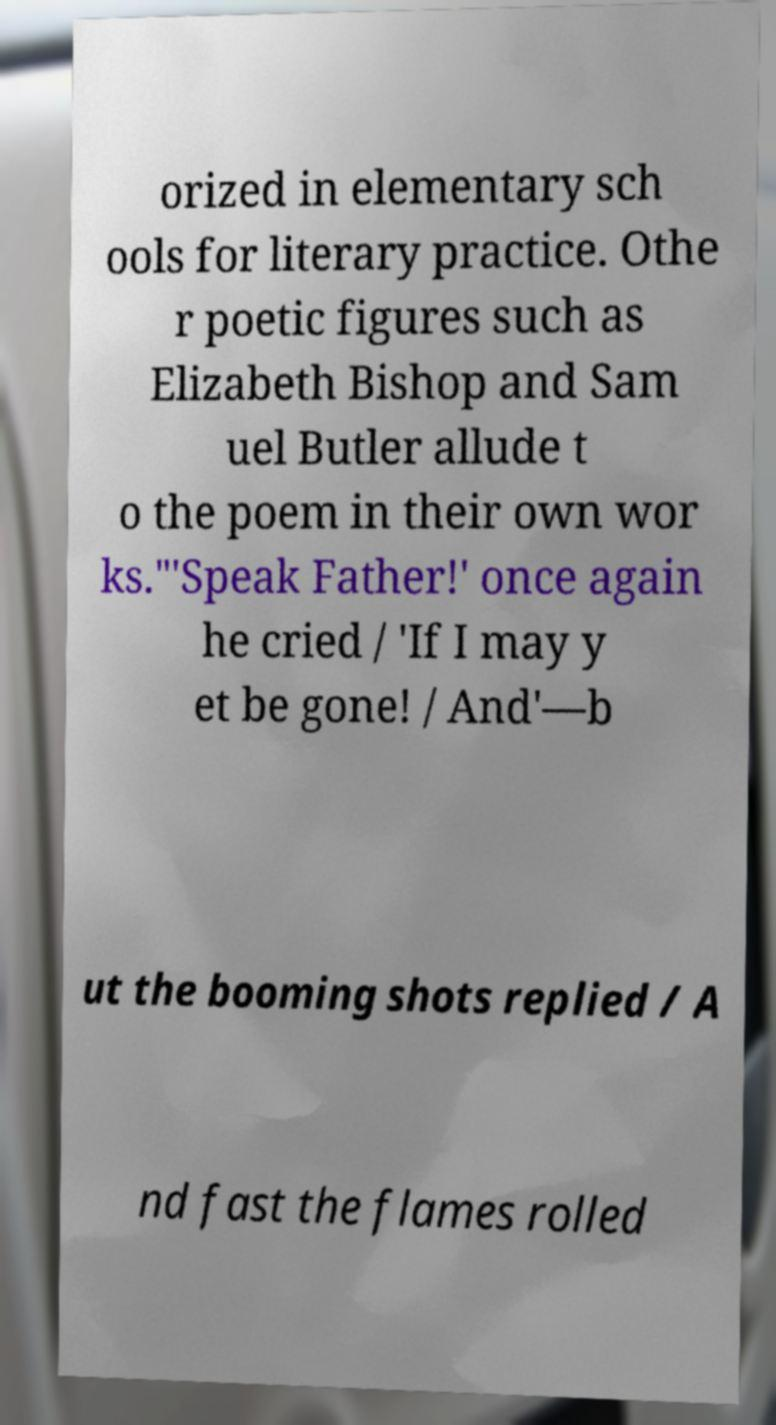Please read and relay the text visible in this image. What does it say? orized in elementary sch ools for literary practice. Othe r poetic figures such as Elizabeth Bishop and Sam uel Butler allude t o the poem in their own wor ks."'Speak Father!' once again he cried / 'If I may y et be gone! / And'—b ut the booming shots replied / A nd fast the flames rolled 